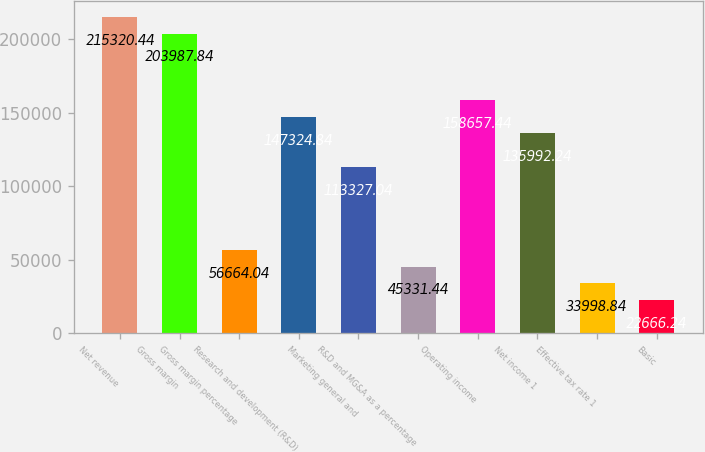Convert chart. <chart><loc_0><loc_0><loc_500><loc_500><bar_chart><fcel>Net revenue<fcel>Gross margin<fcel>Gross margin percentage<fcel>Research and development (R&D)<fcel>Marketing general and<fcel>R&D and MG&A as a percentage<fcel>Operating income<fcel>Net income 1<fcel>Effective tax rate 1<fcel>Basic<nl><fcel>215320<fcel>203988<fcel>56664<fcel>147325<fcel>113327<fcel>45331.4<fcel>158657<fcel>135992<fcel>33998.8<fcel>22666.2<nl></chart> 